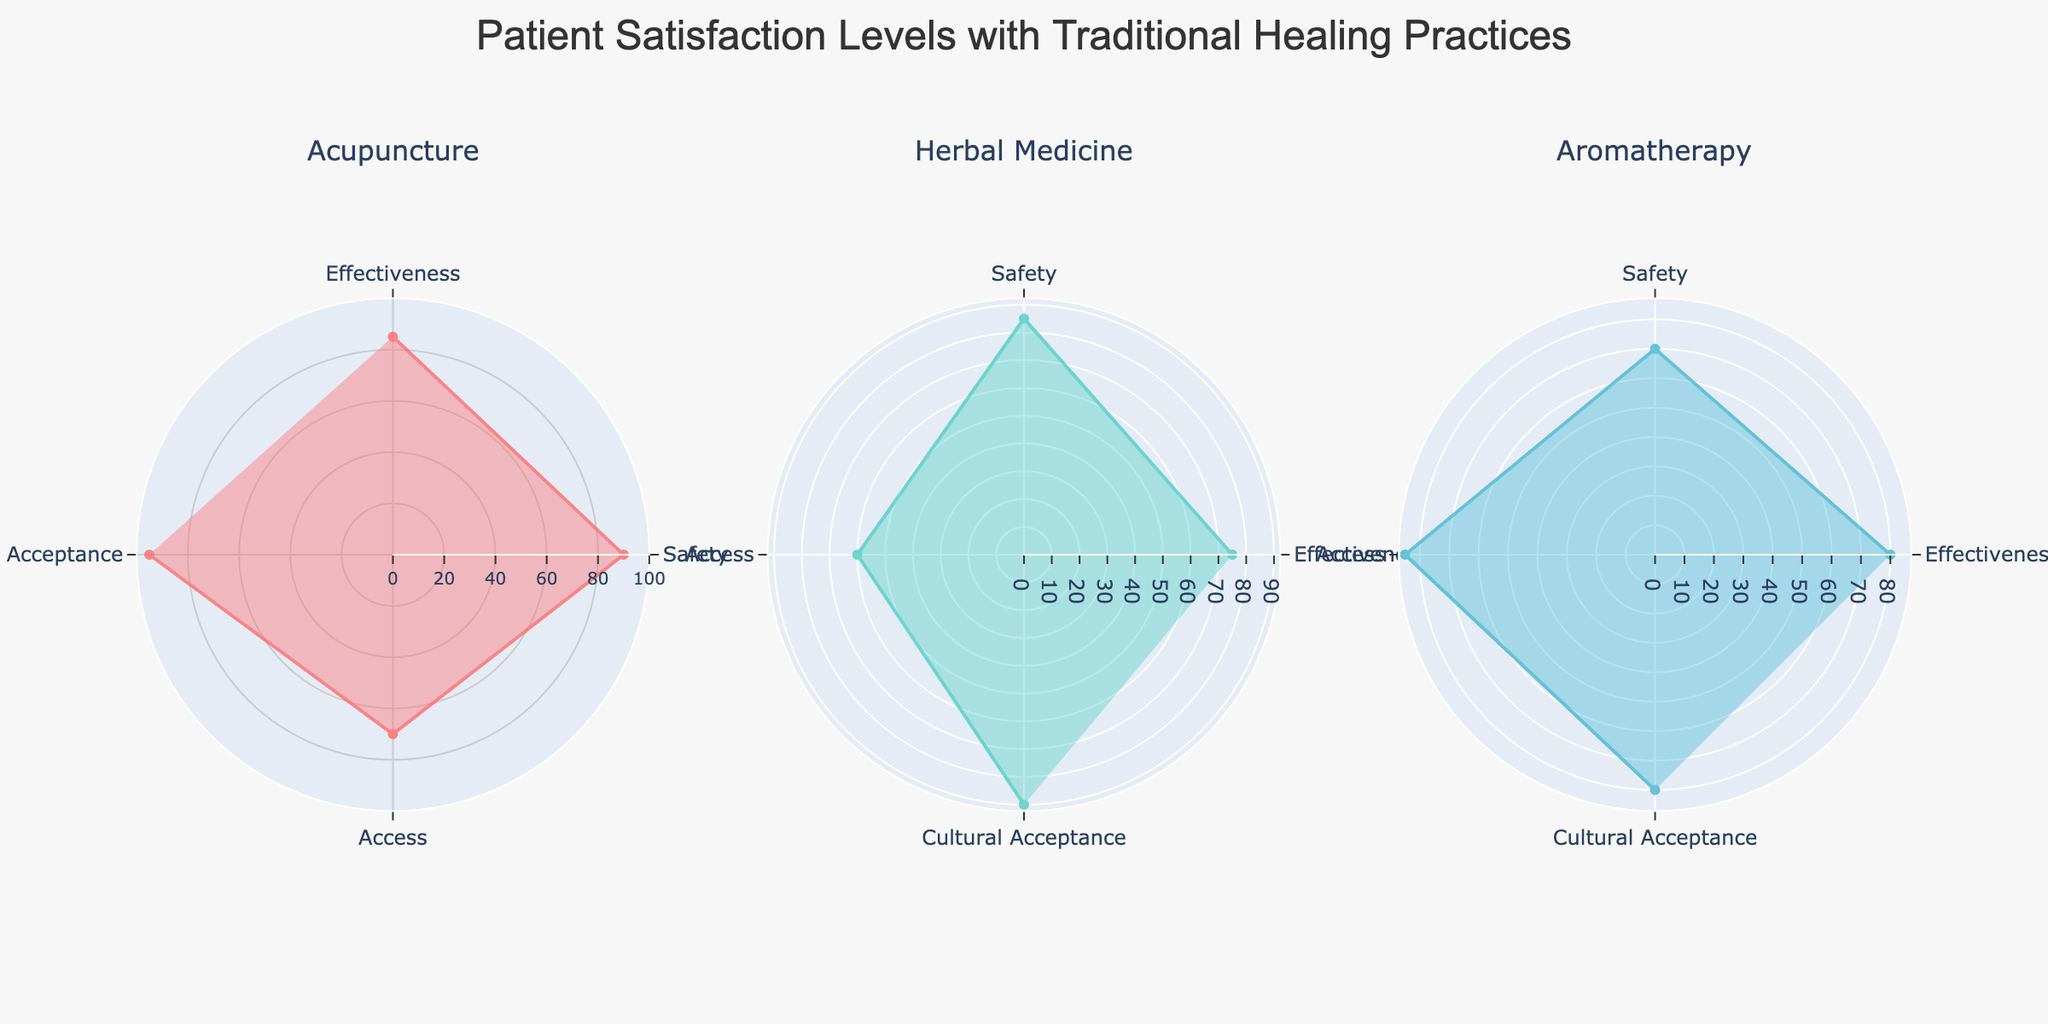What's the title of the figure? The title of the figure is typically placed at the top and summarizes the content of the chart. Here, it reads "Patient Satisfaction Levels with Traditional Healing Practices".
Answer: Patient Satisfaction Levels with Traditional Healing Practices Which therapy scored the highest for cultural acceptance? Compare the values for cultural acceptance across the subplots for each therapy. Acupuncture has the highest score of 95.
Answer: Acupuncture Which category does herbal medicine score the lowest in? Look at the scores for each category in the herbal medicine subplot. The lowest score is in the Access category, where it is 60.
Answer: Access What is the average effectiveness score across all three therapies? Sum the effectiveness scores for Acupuncture (85), Herbal Medicine (75), and Aromatherapy (80), then divide by 3. (85 + 75 + 80) / 3 = 80
Answer: 80 Between acupuncture and aromatherapy, which therapy is safer according to the figure? Compare the safety scores of acupuncture (90) and aromatherapy (70). Acupuncture has a higher safety score.
Answer: Acupuncture What is the difference in access scores between acupuncture and herbal medicine? Subtract the access score of herbal medicine (60) from that of acupuncture (70). 70 - 60 = 10
Answer: 10 Which therapy shows the most balanced scores across all categories? To determine balance, look for therapies that have similar scores across all categories. Acupuncture and Aromatherapy have relatively balanced scores, but Acupuncture is more consistent.
Answer: Acupuncture In which category does aromatherapy score the highest? Look at the scores for each category in the aromatherapy subplot. The highest score is in the Access category, where it is 85.
Answer: Access What can you infer about patient satisfaction with the safety of traditional healing practices? All therapies have generally high safety scores, with acupuncture scoring the highest. This suggests that patients perceive traditional healing practices as safe overall.
Answer: High safety scores 